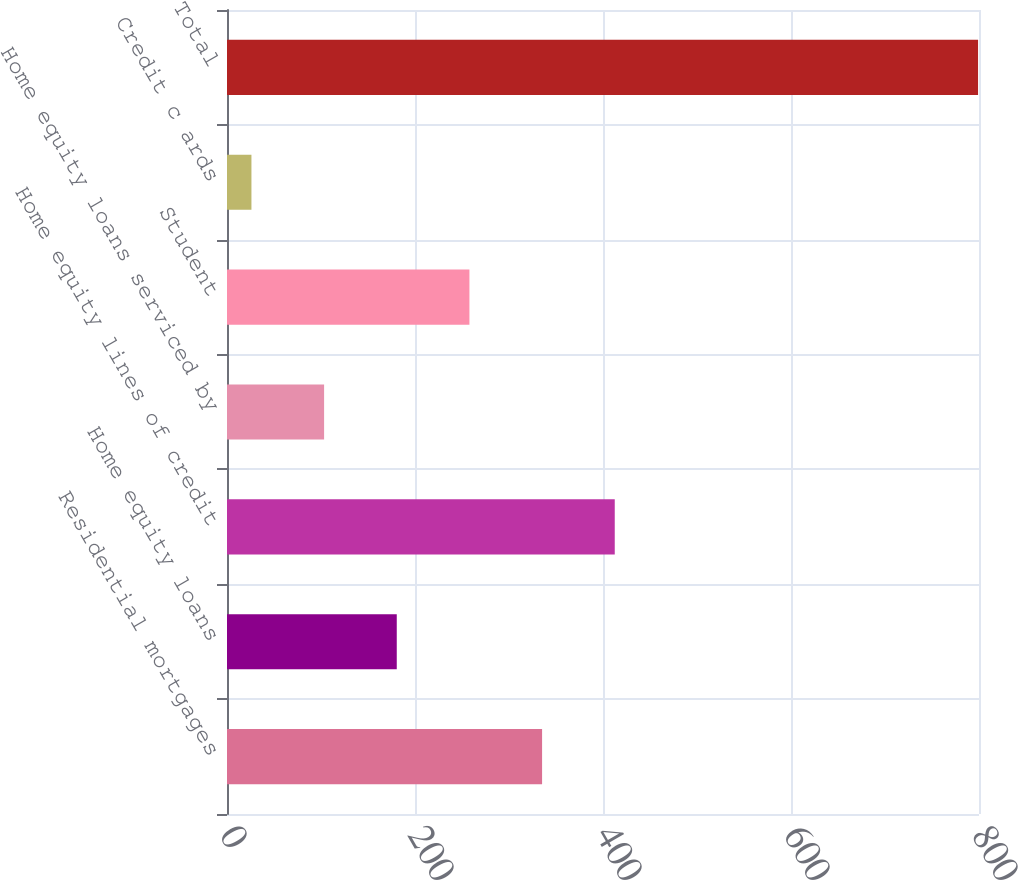Convert chart to OTSL. <chart><loc_0><loc_0><loc_500><loc_500><bar_chart><fcel>Residential mortgages<fcel>Home equity loans<fcel>Home equity lines of credit<fcel>Home equity loans serviced by<fcel>Student<fcel>Credit c ards<fcel>Total<nl><fcel>335.2<fcel>180.6<fcel>412.5<fcel>103.3<fcel>257.9<fcel>26<fcel>799<nl></chart> 